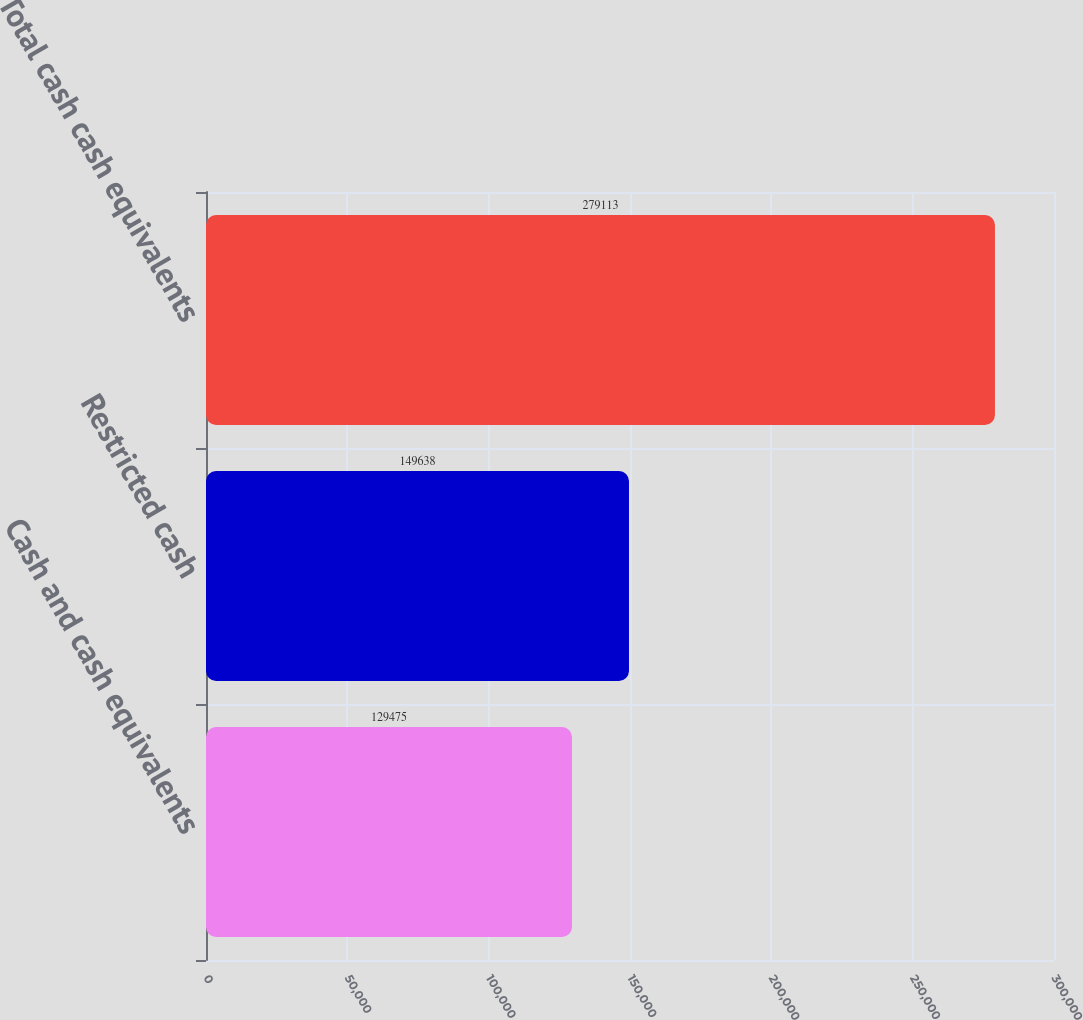Convert chart to OTSL. <chart><loc_0><loc_0><loc_500><loc_500><bar_chart><fcel>Cash and cash equivalents<fcel>Restricted cash<fcel>Total cash cash equivalents<nl><fcel>129475<fcel>149638<fcel>279113<nl></chart> 